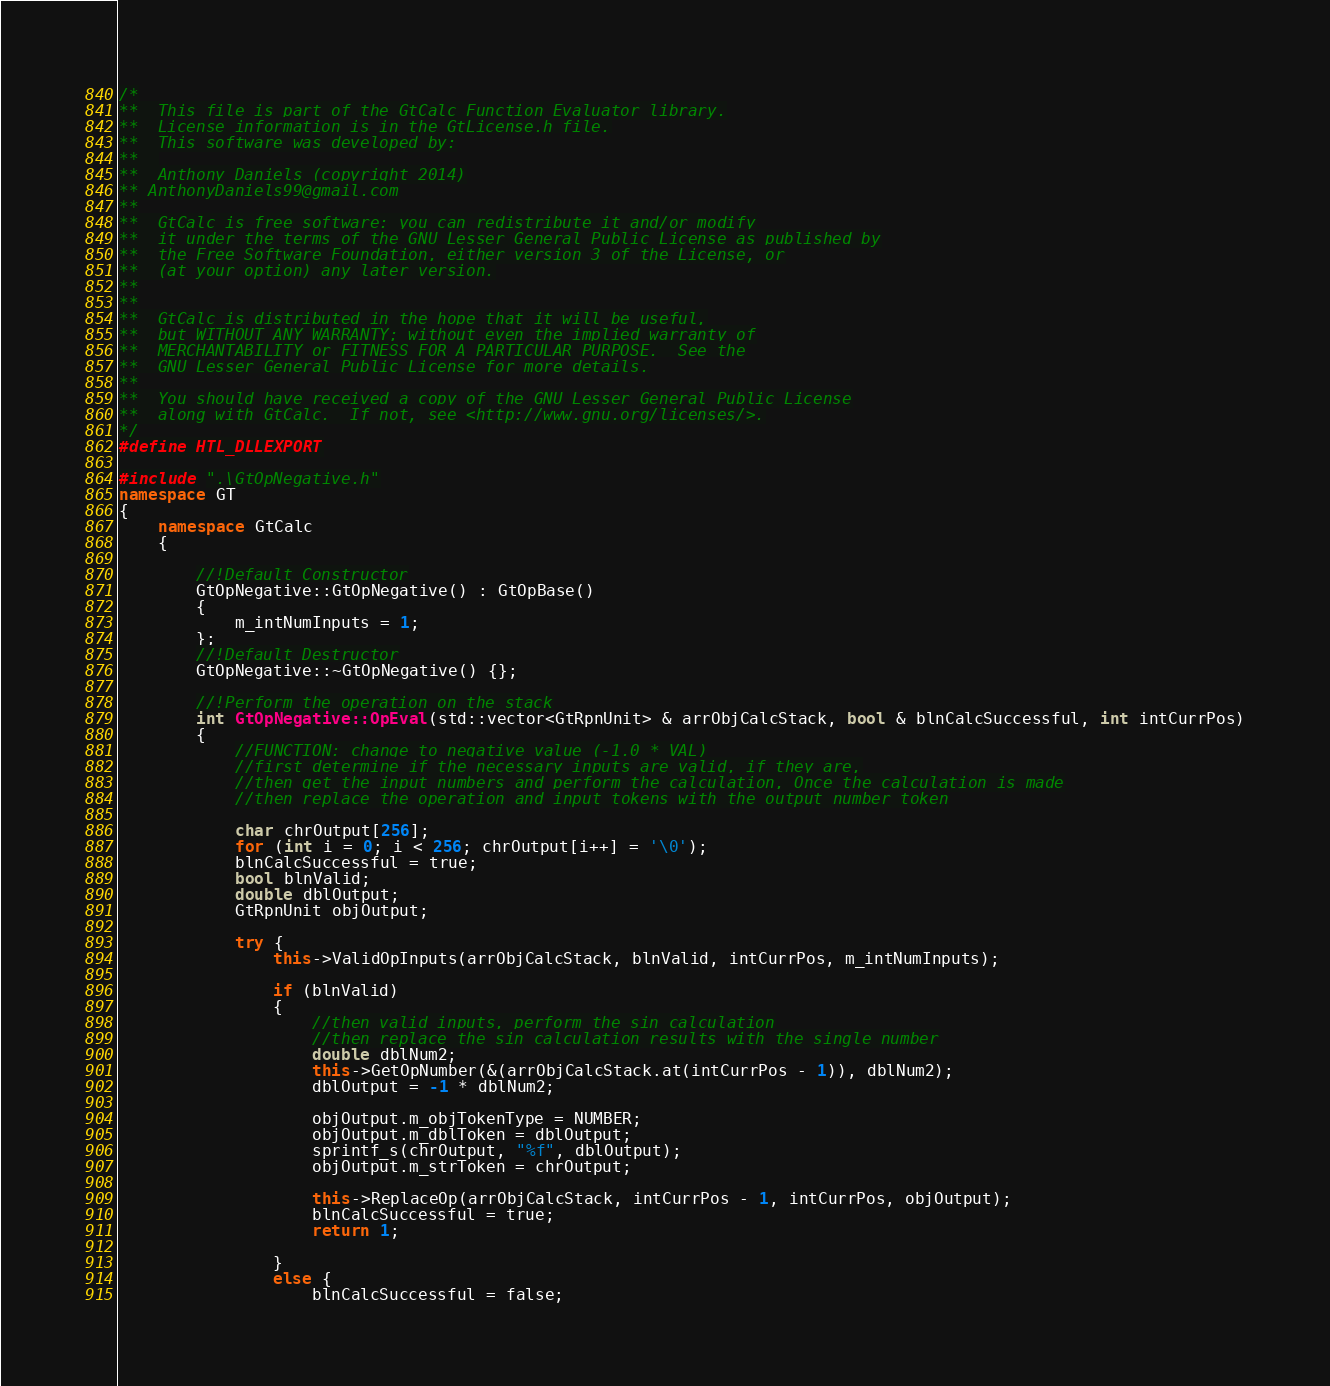Convert code to text. <code><loc_0><loc_0><loc_500><loc_500><_C++_>/*
**	This file is part of the GtCalc Function Evaluator library.
**  License information is in the GtLicense.h file.
**	This software was developed by:
**	
**  Anthony Daniels (copyright 2014)
** AnthonyDaniels99@gmail.com
**
**  GtCalc is free software: you can redistribute it and/or modify
**  it under the terms of the GNU Lesser General Public License as published by
**  the Free Software Foundation, either version 3 of the License, or
**  (at your option) any later version.
**
**
**  GtCalc is distributed in the hope that it will be useful,
**  but WITHOUT ANY WARRANTY; without even the implied warranty of
**  MERCHANTABILITY or FITNESS FOR A PARTICULAR PURPOSE.  See the
**  GNU Lesser General Public License for more details.
**
**  You should have received a copy of the GNU Lesser General Public License
**  along with GtCalc.  If not, see <http://www.gnu.org/licenses/>.
*/
#define HTL_DLLEXPORT

#include ".\GtOpNegative.h"
namespace GT
{
	namespace GtCalc
	{

		//!Default Constructor
		GtOpNegative::GtOpNegative() : GtOpBase()
		{
			m_intNumInputs = 1;
		};
		//!Default Destructor
		GtOpNegative::~GtOpNegative() {};

		//!Perform the operation on the stack
		int GtOpNegative::OpEval(std::vector<GtRpnUnit> & arrObjCalcStack, bool & blnCalcSuccessful, int intCurrPos)
		{
			//FUNCTION: change to negative value (-1.0 * VAL)
			//first determine if the necessary inputs are valid, if they are,
			//then get the input numbers and perform the calculation, Once the calculation is made
			//then replace the operation and input tokens with the output number token

			char chrOutput[256];
			for (int i = 0; i < 256; chrOutput[i++] = '\0');
			blnCalcSuccessful = true;
			bool blnValid;
			double dblOutput;
			GtRpnUnit objOutput;

			try {
				this->ValidOpInputs(arrObjCalcStack, blnValid, intCurrPos, m_intNumInputs);

				if (blnValid)
				{
					//then valid inputs, perform the sin calculation
					//then replace the sin calculation results with the single number
					double dblNum2;
					this->GetOpNumber(&(arrObjCalcStack.at(intCurrPos - 1)), dblNum2);
					dblOutput = -1 * dblNum2;

					objOutput.m_objTokenType = NUMBER;
					objOutput.m_dblToken = dblOutput;
					sprintf_s(chrOutput, "%f", dblOutput);
					objOutput.m_strToken = chrOutput;

					this->ReplaceOp(arrObjCalcStack, intCurrPos - 1, intCurrPos, objOutput);
					blnCalcSuccessful = true;
					return 1;

				}
				else {
					blnCalcSuccessful = false;</code> 